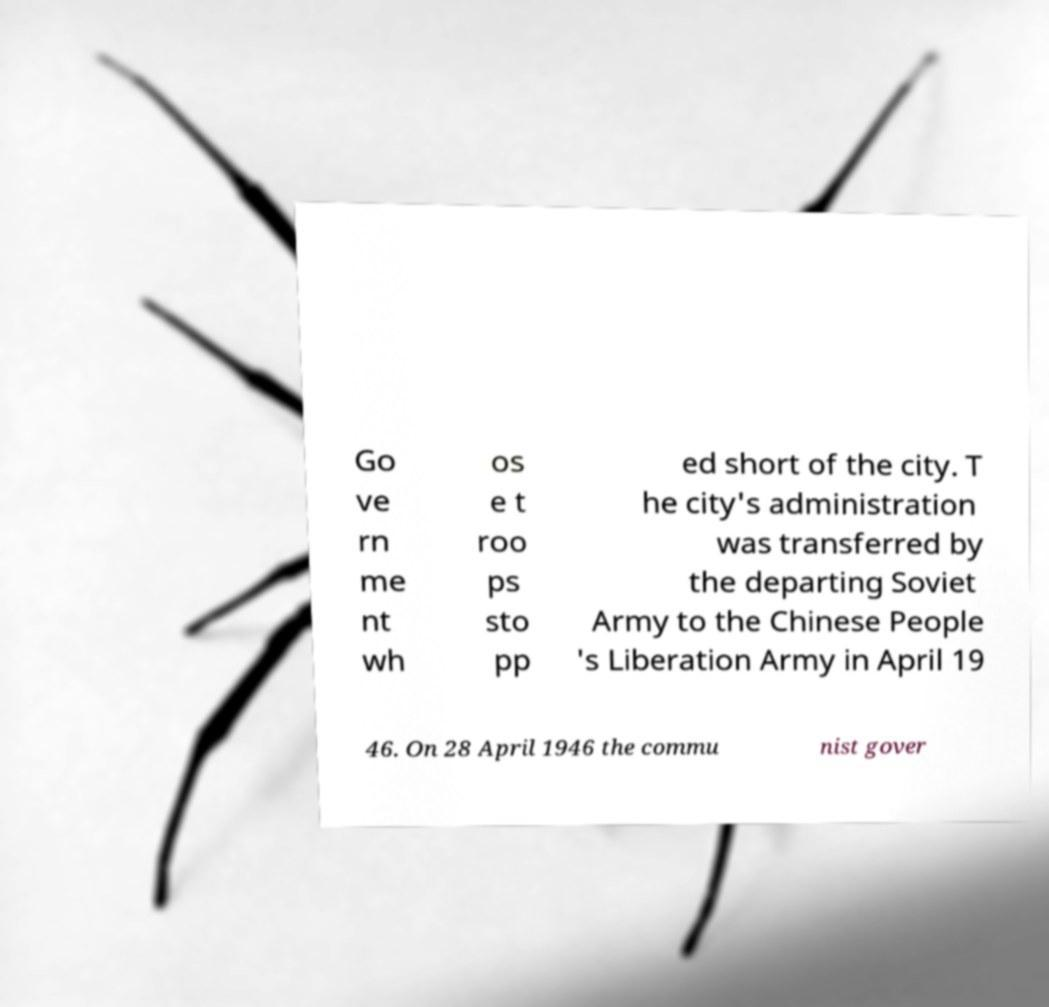Could you extract and type out the text from this image? Go ve rn me nt wh os e t roo ps sto pp ed short of the city. T he city's administration was transferred by the departing Soviet Army to the Chinese People 's Liberation Army in April 19 46. On 28 April 1946 the commu nist gover 